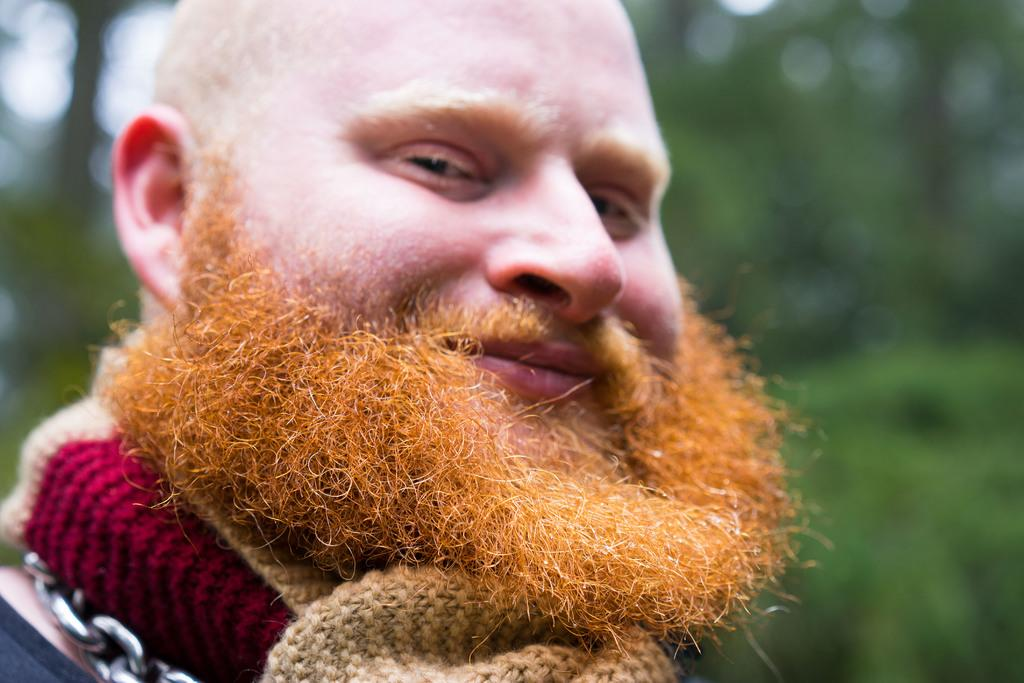Who is present in the image? There is a man in the image. What is the man's facial expression? The man is smiling. Can you describe the background of the image? The background of the image is blurred. What type of environment can be seen in the background? There is greenery visible in the background. What type of whip is the man holding in the image? There is no whip present in the image; the man is not holding any object. Is there a party happening in the image? There is no indication of a party in the image; it only features a man smiling in front of a blurred background with greenery. 